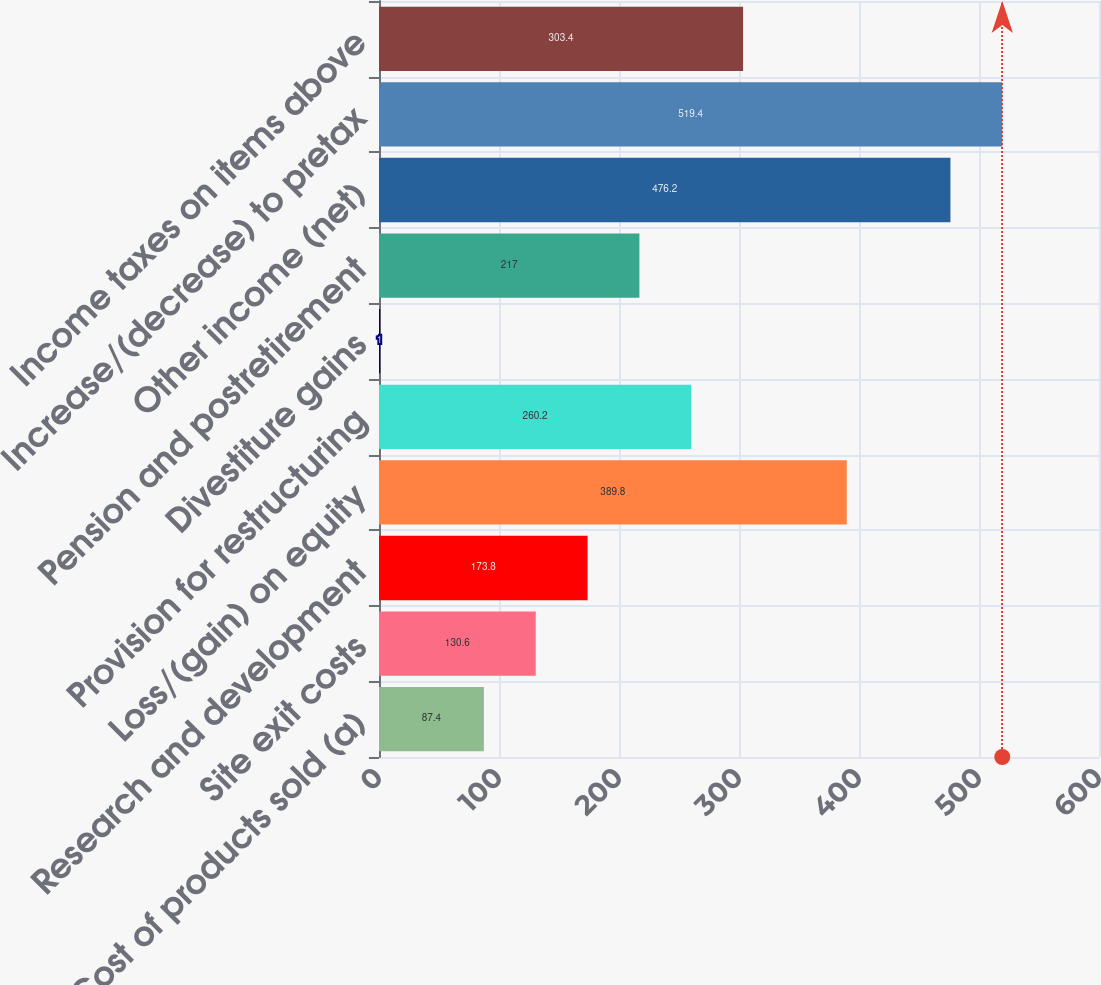Convert chart. <chart><loc_0><loc_0><loc_500><loc_500><bar_chart><fcel>Cost of products sold (a)<fcel>Site exit costs<fcel>Research and development<fcel>Loss/(gain) on equity<fcel>Provision for restructuring<fcel>Divestiture gains<fcel>Pension and postretirement<fcel>Other income (net)<fcel>Increase/(decrease) to pretax<fcel>Income taxes on items above<nl><fcel>87.4<fcel>130.6<fcel>173.8<fcel>389.8<fcel>260.2<fcel>1<fcel>217<fcel>476.2<fcel>519.4<fcel>303.4<nl></chart> 